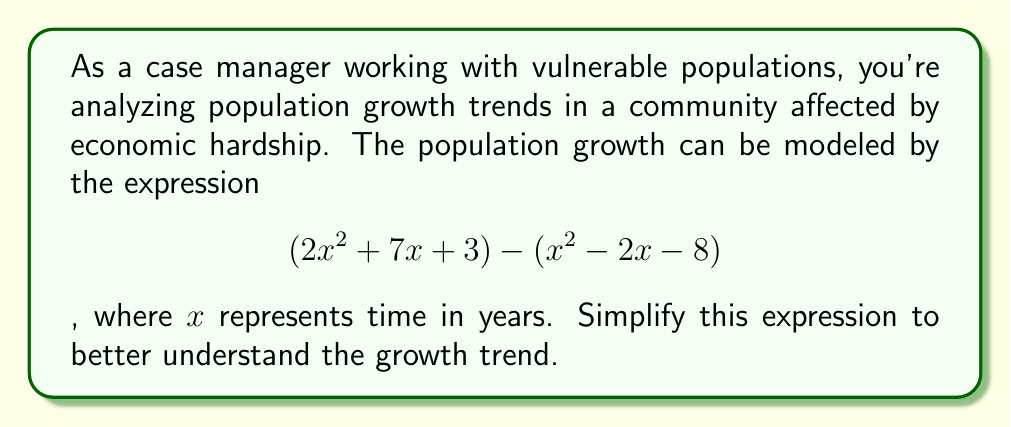Show me your answer to this math problem. Let's simplify this expression step by step:

1) We start with the given expression:
   $$(2x^2 + 7x + 3) - (x^2 - 2x - 8)$$

2) To subtract polynomials, we subtract the corresponding terms. Remember that subtracting a negative is the same as adding a positive:
   $$2x^2 + 7x + 3 - x^2 + 2x + 8$$

3) Now, let's group like terms:
   $$(2x^2 - x^2) + (7x + 2x) + (3 + 8)$$

4) Simplify each group:
   $$x^2 + 9x + 11$$

This simplified polynomial represents the population growth trend in the vulnerable community over time.
Answer: $$x^2 + 9x + 11$$ 